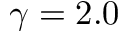<formula> <loc_0><loc_0><loc_500><loc_500>\gamma = 2 . 0</formula> 